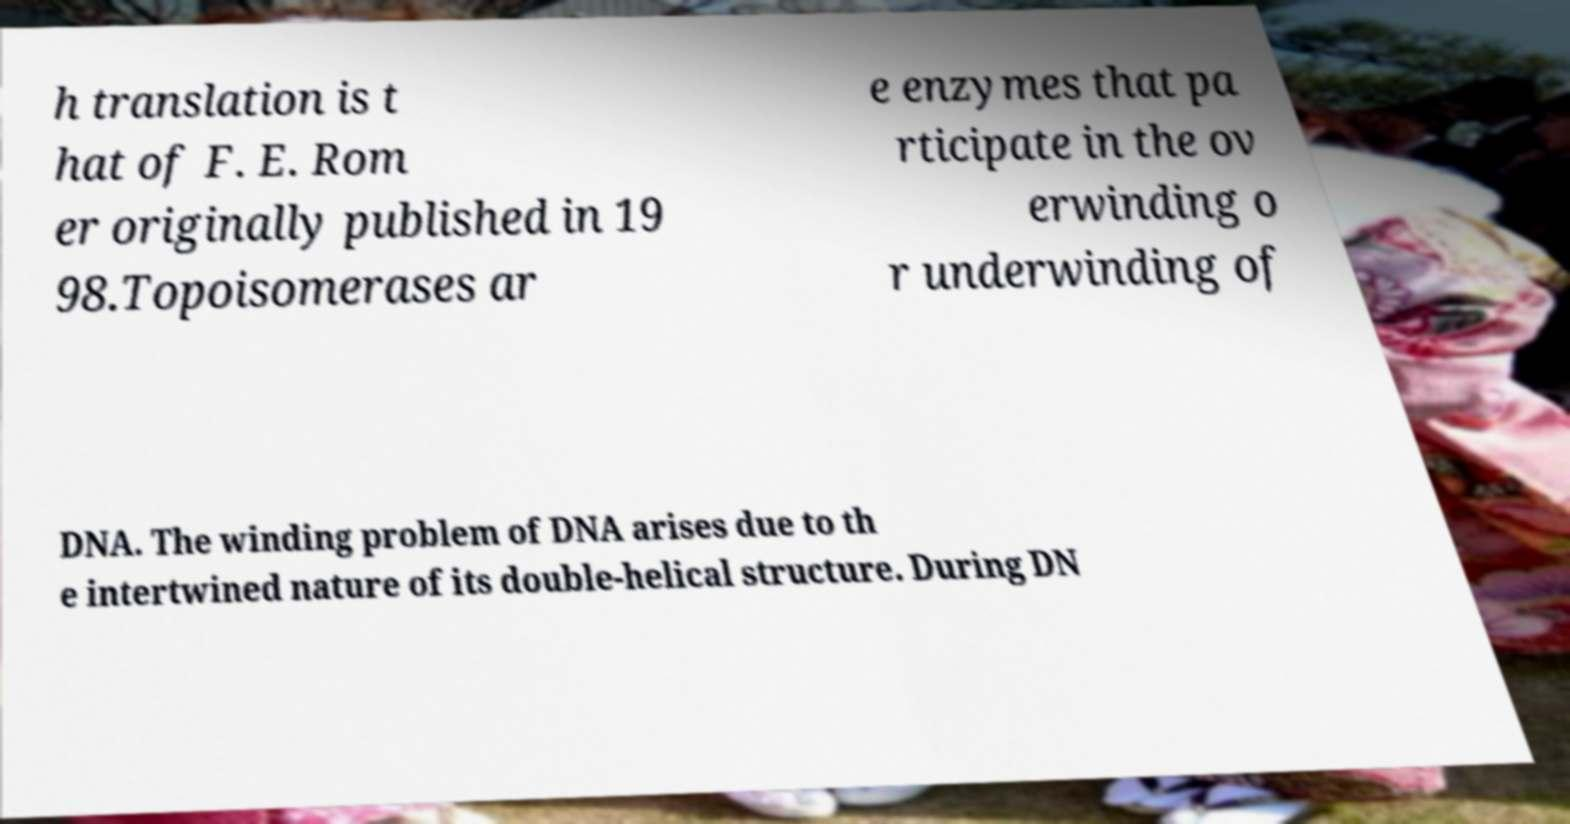I need the written content from this picture converted into text. Can you do that? h translation is t hat of F. E. Rom er originally published in 19 98.Topoisomerases ar e enzymes that pa rticipate in the ov erwinding o r underwinding of DNA. The winding problem of DNA arises due to th e intertwined nature of its double-helical structure. During DN 